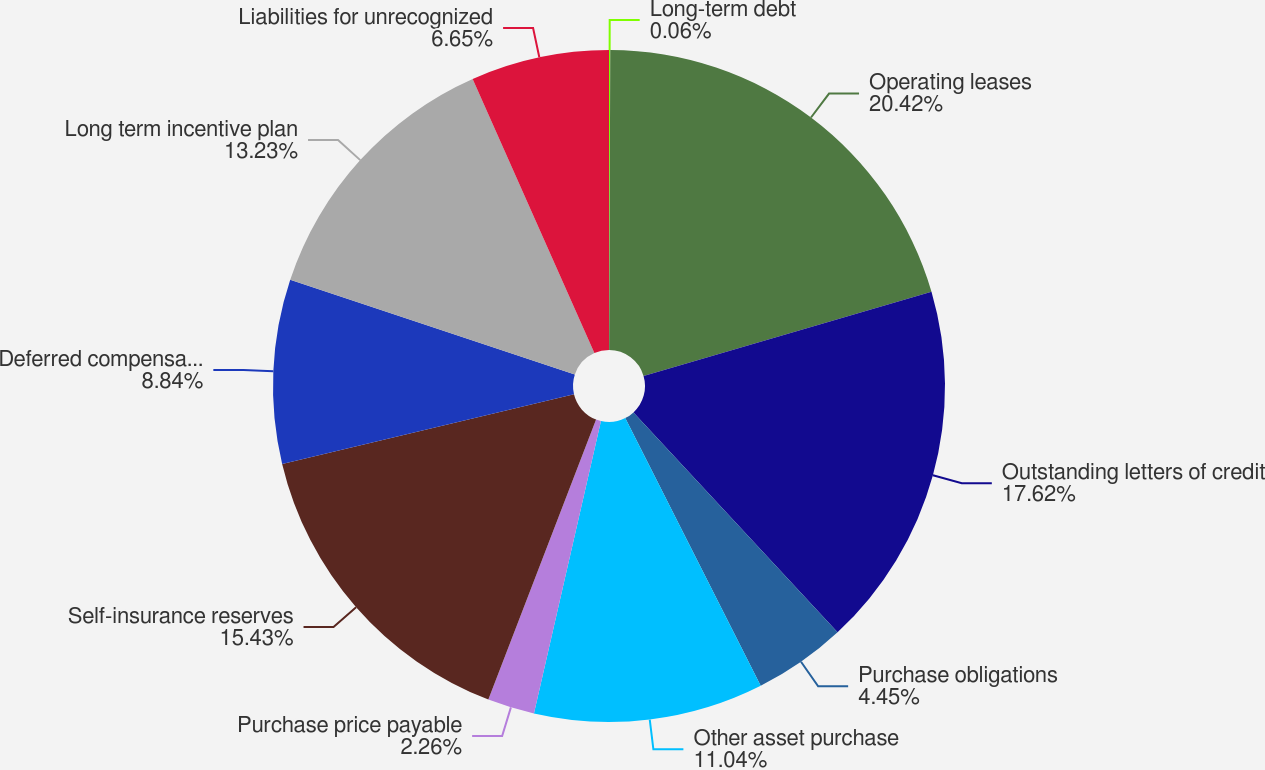<chart> <loc_0><loc_0><loc_500><loc_500><pie_chart><fcel>Long-term debt<fcel>Operating leases<fcel>Outstanding letters of credit<fcel>Purchase obligations<fcel>Other asset purchase<fcel>Purchase price payable<fcel>Self-insurance reserves<fcel>Deferred compensation plans<fcel>Long term incentive plan<fcel>Liabilities for unrecognized<nl><fcel>0.06%<fcel>20.41%<fcel>17.62%<fcel>4.45%<fcel>11.04%<fcel>2.26%<fcel>15.43%<fcel>8.84%<fcel>13.23%<fcel>6.65%<nl></chart> 